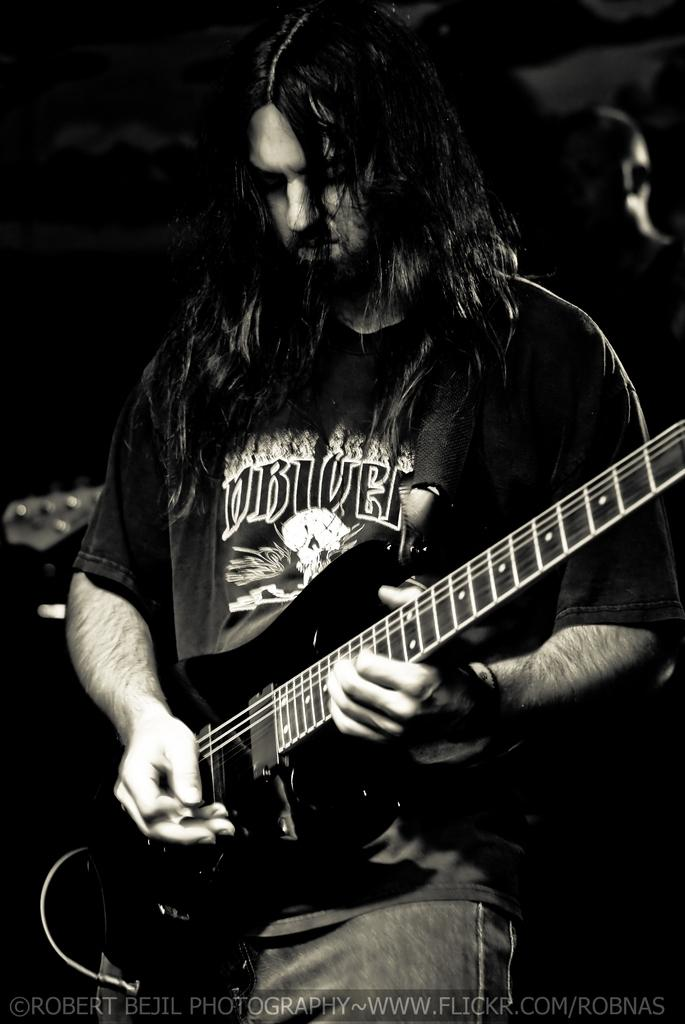What is the man in the picture doing? The man is playing a guitar. What is the color scheme of the picture? The picture is black and white. What type of lipstick is the man wearing in the picture? There is no lipstick or indication of the man wearing lipstick in the picture, as it is a black and white image of a man playing a guitar. 